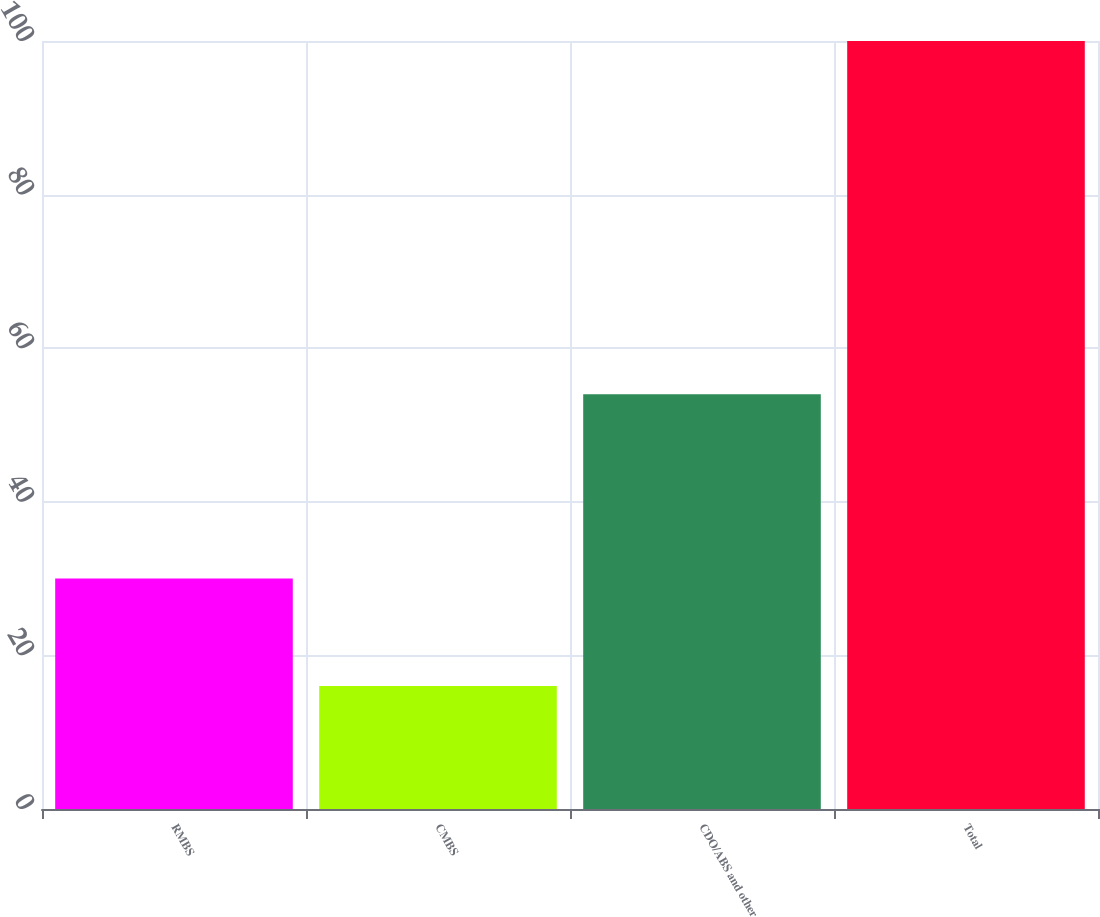Convert chart. <chart><loc_0><loc_0><loc_500><loc_500><bar_chart><fcel>RMBS<fcel>CMBS<fcel>CDO/ABS and other<fcel>Total<nl><fcel>30<fcel>16<fcel>54<fcel>100<nl></chart> 